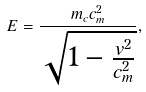Convert formula to latex. <formula><loc_0><loc_0><loc_500><loc_500>E = \frac { m _ { c } c _ { m } ^ { 2 } } { \sqrt { 1 - \frac { v ^ { 2 } } { c _ { m } ^ { 2 } } } } ,</formula> 